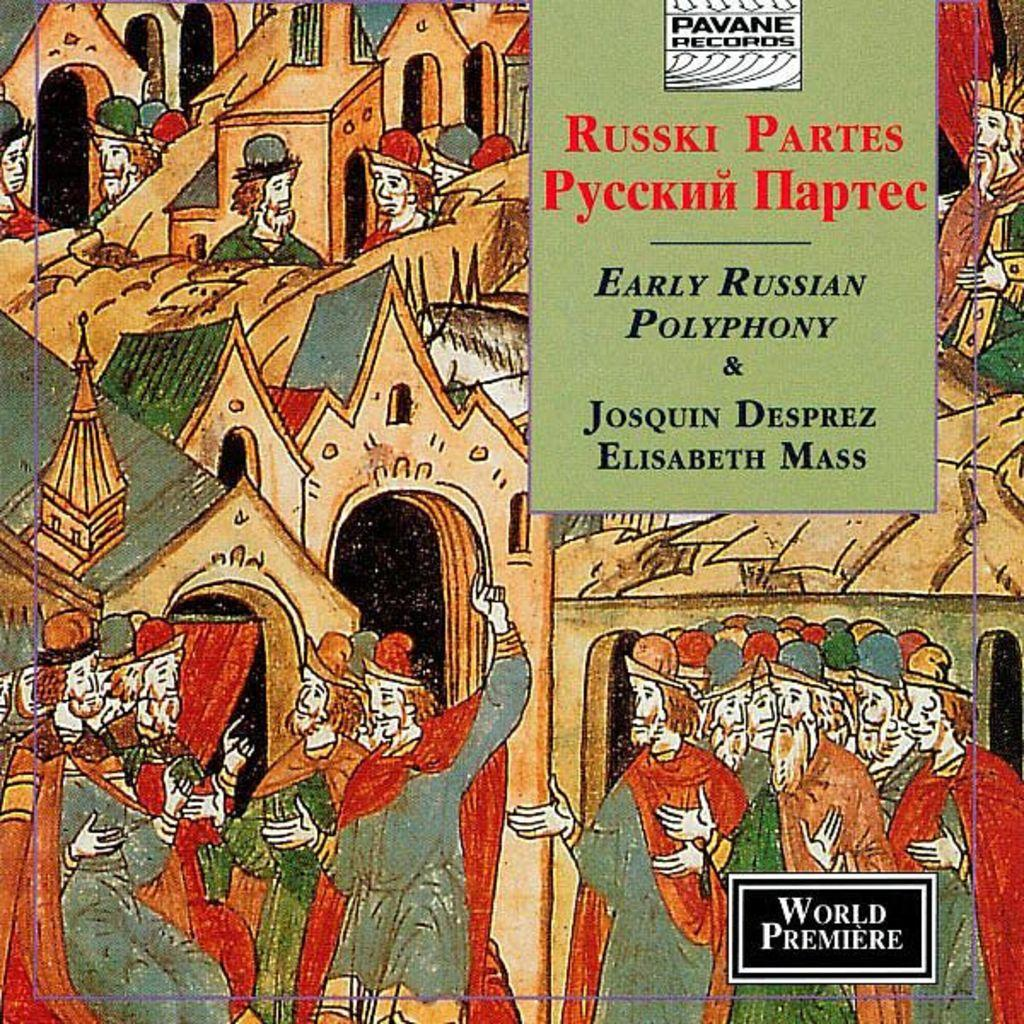<image>
Provide a brief description of the given image. A world premiere record has an animated cover. 